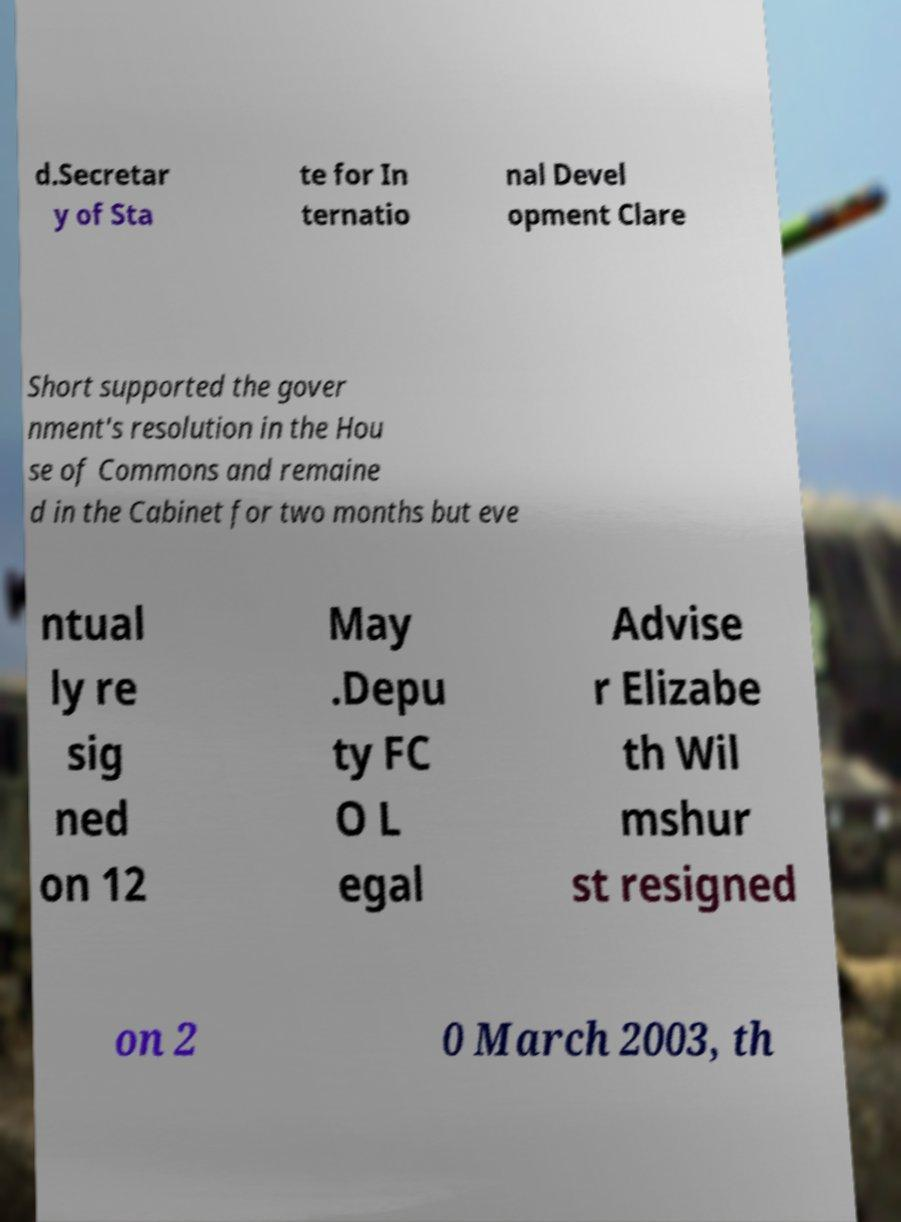What messages or text are displayed in this image? I need them in a readable, typed format. d.Secretar y of Sta te for In ternatio nal Devel opment Clare Short supported the gover nment's resolution in the Hou se of Commons and remaine d in the Cabinet for two months but eve ntual ly re sig ned on 12 May .Depu ty FC O L egal Advise r Elizabe th Wil mshur st resigned on 2 0 March 2003, th 